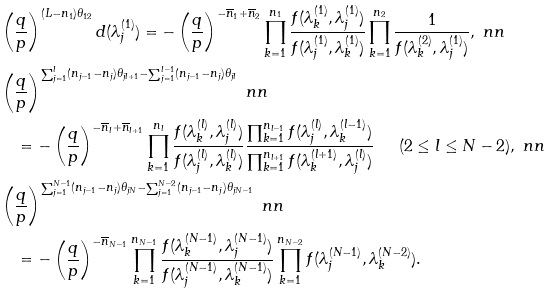<formula> <loc_0><loc_0><loc_500><loc_500>& \left ( \frac { q } { p } \right ) ^ { ( L - n _ { 1 } ) \theta _ { 1 2 } } d ( \lambda _ { j } ^ { ( 1 ) } ) = - \left ( \frac { q } { p } \right ) ^ { - \overline { n } _ { 1 } + \overline { n } _ { 2 } } \prod _ { k = 1 } ^ { n _ { 1 } } \frac { f ( \lambda _ { k } ^ { ( 1 ) } , \lambda _ { j } ^ { ( 1 ) } ) } { f ( \lambda _ { j } ^ { ( 1 ) } , \lambda _ { k } ^ { ( 1 ) } ) } \prod _ { k = 1 } ^ { n _ { 2 } } \frac { 1 } { f ( \lambda _ { k } ^ { ( 2 ) } , \lambda _ { j } ^ { ( 1 ) } ) } , \ n n \\ & \left ( \frac { q } { p } \right ) ^ { \sum _ { j = 1 } ^ { l } ( n _ { j - 1 } - n _ { j } ) \theta _ { j l + 1 } - \sum _ { j = 1 } ^ { l - 1 } ( n _ { j - 1 } - n _ { j } ) \theta _ { j l } } \ n n \\ & \quad = - \left ( \frac { q } { p } \right ) ^ { - \overline { n } _ { l } + \overline { n } _ { l + 1 } } \prod _ { k = 1 } ^ { n _ { l } } \frac { f ( \lambda _ { k } ^ { ( l ) } , \lambda _ { j } ^ { ( l ) } ) } { f ( \lambda _ { j } ^ { ( l ) } , \lambda _ { k } ^ { ( l ) } ) } \frac { \prod _ { k = 1 } ^ { n _ { l - 1 } } f ( \lambda _ { j } ^ { ( l ) } , \lambda _ { k } ^ { ( l - 1 ) } ) } { \prod _ { k = 1 } ^ { n _ { l + 1 } } f ( \lambda _ { k } ^ { ( l + 1 ) } , \lambda _ { j } ^ { ( l ) } ) } \quad \text {\, ($2\leq l \leq N-2$)} , \ n n \\ & \left ( \frac { q } { p } \right ) ^ { \sum _ { j = 1 } ^ { N - 1 } ( n _ { j - 1 } - n _ { j } ) \theta _ { j N } - \sum _ { j = 1 } ^ { N - 2 } ( n _ { j - 1 } - n _ { j } ) \theta _ { j N - 1 } } \ n n \\ & \quad = - \left ( \frac { q } { p } \right ) ^ { - \overline { n } _ { N - 1 } } \prod _ { k = 1 } ^ { n _ { N - 1 } } \frac { f ( \lambda _ { k } ^ { ( N - 1 ) } , \lambda _ { j } ^ { ( N - 1 ) } ) } { f ( \lambda _ { j } ^ { ( N - 1 ) } , \lambda _ { k } ^ { ( N - 1 ) } ) } \prod _ { k = 1 } ^ { n _ { N - 2 } } f ( \lambda _ { j } ^ { ( N - 1 ) } , \lambda _ { k } ^ { ( N - 2 ) } ) .</formula> 